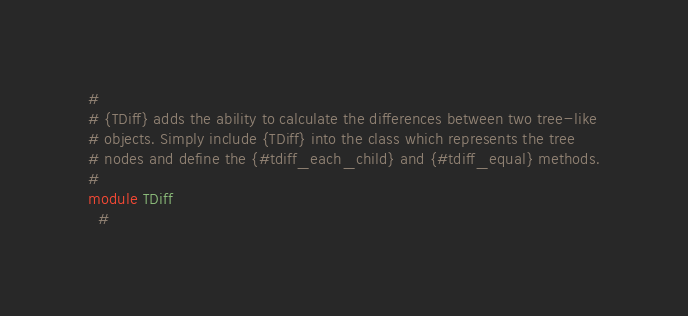<code> <loc_0><loc_0><loc_500><loc_500><_Ruby_>#
# {TDiff} adds the ability to calculate the differences between two tree-like
# objects. Simply include {TDiff} into the class which represents the tree
# nodes and define the {#tdiff_each_child} and {#tdiff_equal} methods.
#
module TDiff
  #</code> 